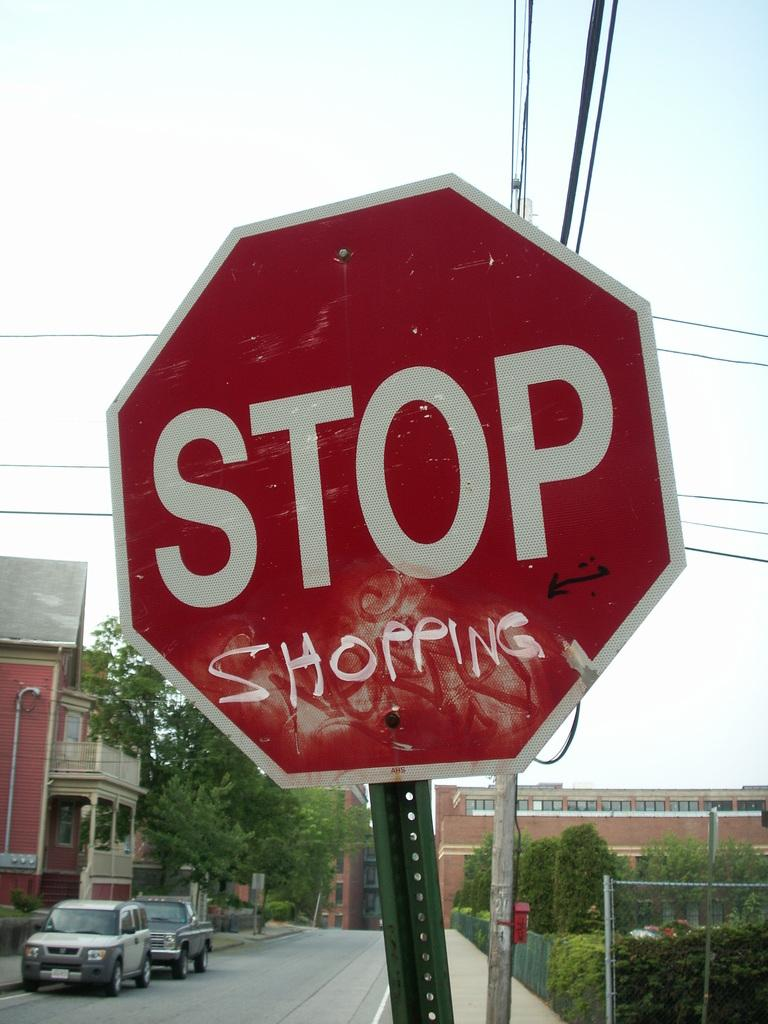<image>
Give a short and clear explanation of the subsequent image. A red stop say says Shopping in handwritten painted letters. 